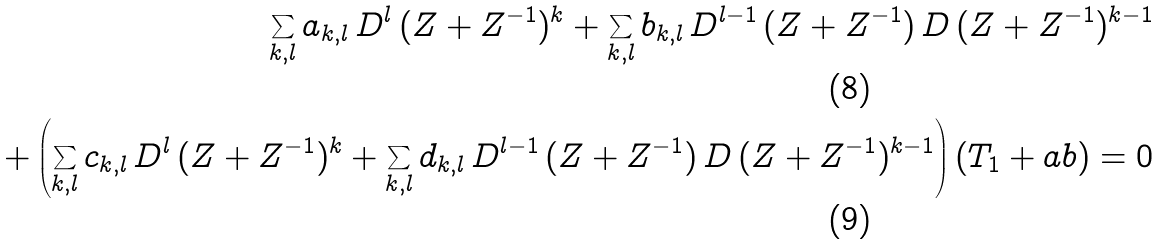Convert formula to latex. <formula><loc_0><loc_0><loc_500><loc_500>\sum _ { k , l } a _ { k , l } \, D ^ { l } \, ( Z + Z ^ { - 1 } ) ^ { k } + \sum _ { k , l } b _ { k , l } \, D ^ { l - 1 } \, ( Z + Z ^ { - 1 } ) \, D \, ( Z + Z ^ { - 1 } ) ^ { k - 1 } \\ + \left ( \sum _ { k , l } c _ { k , l } \, D ^ { l } \, ( Z + Z ^ { - 1 } ) ^ { k } + \sum _ { k , l } d _ { k , l } \, D ^ { l - 1 } \, ( Z + Z ^ { - 1 } ) \, D \, ( Z + Z ^ { - 1 } ) ^ { k - 1 } \right ) ( T _ { 1 } + a b ) = 0</formula> 